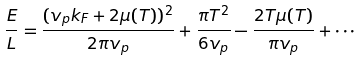<formula> <loc_0><loc_0><loc_500><loc_500>\frac { E } { L } = \frac { ( v _ { p } k _ { F } + 2 \mu ( T ) ) ^ { 2 } } { 2 \pi v _ { p } } + \frac { \pi T ^ { 2 } } { 6 v _ { p } } - \frac { 2 T \mu ( T ) } { \pi v _ { p } } + \cdots</formula> 